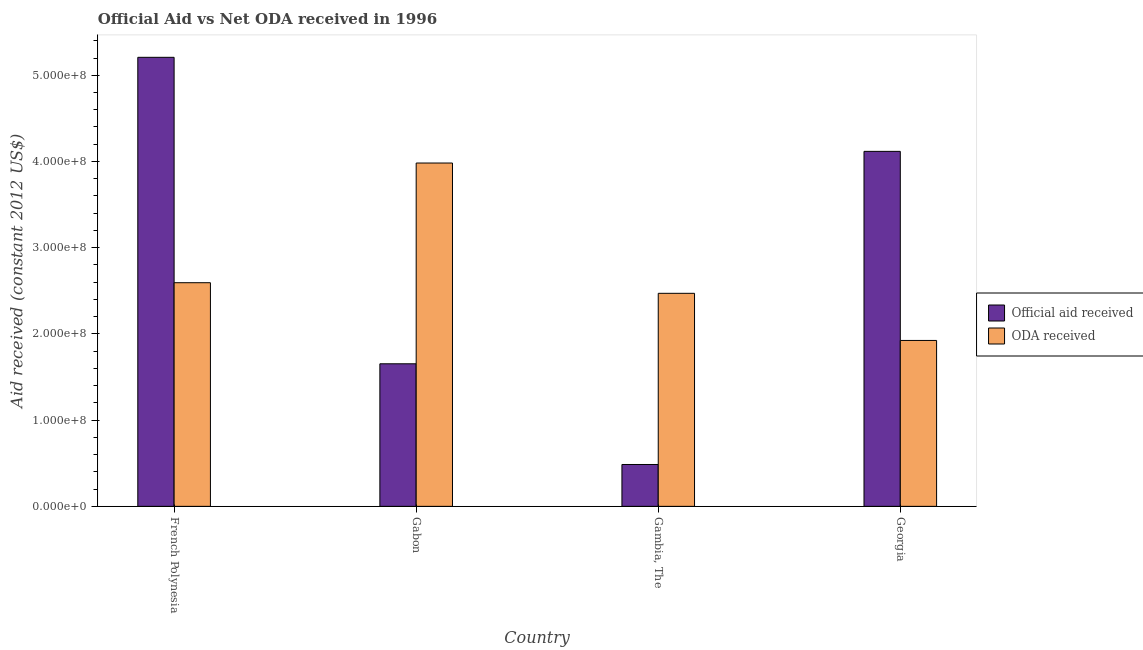How many different coloured bars are there?
Give a very brief answer. 2. How many groups of bars are there?
Offer a very short reply. 4. Are the number of bars on each tick of the X-axis equal?
Your response must be concise. Yes. What is the label of the 1st group of bars from the left?
Keep it short and to the point. French Polynesia. What is the oda received in Georgia?
Make the answer very short. 1.92e+08. Across all countries, what is the maximum oda received?
Make the answer very short. 3.98e+08. Across all countries, what is the minimum oda received?
Your answer should be compact. 1.92e+08. In which country was the official aid received maximum?
Your answer should be compact. French Polynesia. In which country was the official aid received minimum?
Make the answer very short. Gambia, The. What is the total official aid received in the graph?
Offer a very short reply. 1.15e+09. What is the difference between the official aid received in French Polynesia and that in Georgia?
Make the answer very short. 1.09e+08. What is the difference between the official aid received in French Polynesia and the oda received in Georgia?
Provide a succinct answer. 3.28e+08. What is the average official aid received per country?
Offer a very short reply. 2.87e+08. What is the difference between the oda received and official aid received in Georgia?
Keep it short and to the point. -2.19e+08. What is the ratio of the oda received in French Polynesia to that in Gabon?
Ensure brevity in your answer.  0.65. Is the difference between the oda received in Gabon and Georgia greater than the difference between the official aid received in Gabon and Georgia?
Your answer should be compact. Yes. What is the difference between the highest and the second highest official aid received?
Make the answer very short. 1.09e+08. What is the difference between the highest and the lowest official aid received?
Your response must be concise. 4.72e+08. In how many countries, is the official aid received greater than the average official aid received taken over all countries?
Your answer should be compact. 2. Is the sum of the oda received in French Polynesia and Gambia, The greater than the maximum official aid received across all countries?
Offer a terse response. No. What does the 2nd bar from the left in French Polynesia represents?
Make the answer very short. ODA received. What does the 2nd bar from the right in Gambia, The represents?
Offer a very short reply. Official aid received. How many bars are there?
Provide a succinct answer. 8. Are all the bars in the graph horizontal?
Your answer should be compact. No. Are the values on the major ticks of Y-axis written in scientific E-notation?
Offer a very short reply. Yes. Where does the legend appear in the graph?
Give a very brief answer. Center right. How many legend labels are there?
Offer a very short reply. 2. What is the title of the graph?
Give a very brief answer. Official Aid vs Net ODA received in 1996 . What is the label or title of the Y-axis?
Offer a very short reply. Aid received (constant 2012 US$). What is the Aid received (constant 2012 US$) in Official aid received in French Polynesia?
Your response must be concise. 5.21e+08. What is the Aid received (constant 2012 US$) in ODA received in French Polynesia?
Offer a very short reply. 2.59e+08. What is the Aid received (constant 2012 US$) in Official aid received in Gabon?
Give a very brief answer. 1.65e+08. What is the Aid received (constant 2012 US$) in ODA received in Gabon?
Your answer should be compact. 3.98e+08. What is the Aid received (constant 2012 US$) of Official aid received in Gambia, The?
Offer a terse response. 4.86e+07. What is the Aid received (constant 2012 US$) in ODA received in Gambia, The?
Offer a terse response. 2.47e+08. What is the Aid received (constant 2012 US$) of Official aid received in Georgia?
Offer a terse response. 4.12e+08. What is the Aid received (constant 2012 US$) in ODA received in Georgia?
Your answer should be very brief. 1.92e+08. Across all countries, what is the maximum Aid received (constant 2012 US$) of Official aid received?
Keep it short and to the point. 5.21e+08. Across all countries, what is the maximum Aid received (constant 2012 US$) in ODA received?
Provide a short and direct response. 3.98e+08. Across all countries, what is the minimum Aid received (constant 2012 US$) of Official aid received?
Offer a very short reply. 4.86e+07. Across all countries, what is the minimum Aid received (constant 2012 US$) in ODA received?
Offer a terse response. 1.92e+08. What is the total Aid received (constant 2012 US$) in Official aid received in the graph?
Provide a succinct answer. 1.15e+09. What is the total Aid received (constant 2012 US$) in ODA received in the graph?
Your answer should be very brief. 1.10e+09. What is the difference between the Aid received (constant 2012 US$) in Official aid received in French Polynesia and that in Gabon?
Make the answer very short. 3.55e+08. What is the difference between the Aid received (constant 2012 US$) of ODA received in French Polynesia and that in Gabon?
Ensure brevity in your answer.  -1.39e+08. What is the difference between the Aid received (constant 2012 US$) of Official aid received in French Polynesia and that in Gambia, The?
Offer a terse response. 4.72e+08. What is the difference between the Aid received (constant 2012 US$) in ODA received in French Polynesia and that in Gambia, The?
Provide a succinct answer. 1.23e+07. What is the difference between the Aid received (constant 2012 US$) in Official aid received in French Polynesia and that in Georgia?
Offer a very short reply. 1.09e+08. What is the difference between the Aid received (constant 2012 US$) of ODA received in French Polynesia and that in Georgia?
Offer a very short reply. 6.70e+07. What is the difference between the Aid received (constant 2012 US$) of Official aid received in Gabon and that in Gambia, The?
Keep it short and to the point. 1.17e+08. What is the difference between the Aid received (constant 2012 US$) in ODA received in Gabon and that in Gambia, The?
Give a very brief answer. 1.51e+08. What is the difference between the Aid received (constant 2012 US$) of Official aid received in Gabon and that in Georgia?
Your answer should be very brief. -2.46e+08. What is the difference between the Aid received (constant 2012 US$) of ODA received in Gabon and that in Georgia?
Your response must be concise. 2.06e+08. What is the difference between the Aid received (constant 2012 US$) of Official aid received in Gambia, The and that in Georgia?
Provide a short and direct response. -3.63e+08. What is the difference between the Aid received (constant 2012 US$) of ODA received in Gambia, The and that in Georgia?
Keep it short and to the point. 5.46e+07. What is the difference between the Aid received (constant 2012 US$) of Official aid received in French Polynesia and the Aid received (constant 2012 US$) of ODA received in Gabon?
Keep it short and to the point. 1.23e+08. What is the difference between the Aid received (constant 2012 US$) of Official aid received in French Polynesia and the Aid received (constant 2012 US$) of ODA received in Gambia, The?
Provide a succinct answer. 2.74e+08. What is the difference between the Aid received (constant 2012 US$) in Official aid received in French Polynesia and the Aid received (constant 2012 US$) in ODA received in Georgia?
Keep it short and to the point. 3.28e+08. What is the difference between the Aid received (constant 2012 US$) in Official aid received in Gabon and the Aid received (constant 2012 US$) in ODA received in Gambia, The?
Your response must be concise. -8.17e+07. What is the difference between the Aid received (constant 2012 US$) of Official aid received in Gabon and the Aid received (constant 2012 US$) of ODA received in Georgia?
Offer a very short reply. -2.71e+07. What is the difference between the Aid received (constant 2012 US$) in Official aid received in Gambia, The and the Aid received (constant 2012 US$) in ODA received in Georgia?
Your answer should be compact. -1.44e+08. What is the average Aid received (constant 2012 US$) in Official aid received per country?
Your answer should be compact. 2.87e+08. What is the average Aid received (constant 2012 US$) of ODA received per country?
Your answer should be very brief. 2.74e+08. What is the difference between the Aid received (constant 2012 US$) in Official aid received and Aid received (constant 2012 US$) in ODA received in French Polynesia?
Keep it short and to the point. 2.61e+08. What is the difference between the Aid received (constant 2012 US$) of Official aid received and Aid received (constant 2012 US$) of ODA received in Gabon?
Give a very brief answer. -2.33e+08. What is the difference between the Aid received (constant 2012 US$) of Official aid received and Aid received (constant 2012 US$) of ODA received in Gambia, The?
Your response must be concise. -1.99e+08. What is the difference between the Aid received (constant 2012 US$) of Official aid received and Aid received (constant 2012 US$) of ODA received in Georgia?
Provide a succinct answer. 2.19e+08. What is the ratio of the Aid received (constant 2012 US$) in Official aid received in French Polynesia to that in Gabon?
Ensure brevity in your answer.  3.15. What is the ratio of the Aid received (constant 2012 US$) of ODA received in French Polynesia to that in Gabon?
Offer a very short reply. 0.65. What is the ratio of the Aid received (constant 2012 US$) of Official aid received in French Polynesia to that in Gambia, The?
Make the answer very short. 10.73. What is the ratio of the Aid received (constant 2012 US$) in ODA received in French Polynesia to that in Gambia, The?
Your response must be concise. 1.05. What is the ratio of the Aid received (constant 2012 US$) of Official aid received in French Polynesia to that in Georgia?
Your answer should be compact. 1.26. What is the ratio of the Aid received (constant 2012 US$) of ODA received in French Polynesia to that in Georgia?
Your answer should be very brief. 1.35. What is the ratio of the Aid received (constant 2012 US$) of Official aid received in Gabon to that in Gambia, The?
Ensure brevity in your answer.  3.41. What is the ratio of the Aid received (constant 2012 US$) of ODA received in Gabon to that in Gambia, The?
Your answer should be compact. 1.61. What is the ratio of the Aid received (constant 2012 US$) in Official aid received in Gabon to that in Georgia?
Provide a short and direct response. 0.4. What is the ratio of the Aid received (constant 2012 US$) of ODA received in Gabon to that in Georgia?
Offer a terse response. 2.07. What is the ratio of the Aid received (constant 2012 US$) of Official aid received in Gambia, The to that in Georgia?
Ensure brevity in your answer.  0.12. What is the ratio of the Aid received (constant 2012 US$) in ODA received in Gambia, The to that in Georgia?
Provide a short and direct response. 1.28. What is the difference between the highest and the second highest Aid received (constant 2012 US$) of Official aid received?
Your answer should be very brief. 1.09e+08. What is the difference between the highest and the second highest Aid received (constant 2012 US$) in ODA received?
Provide a short and direct response. 1.39e+08. What is the difference between the highest and the lowest Aid received (constant 2012 US$) in Official aid received?
Offer a terse response. 4.72e+08. What is the difference between the highest and the lowest Aid received (constant 2012 US$) in ODA received?
Provide a succinct answer. 2.06e+08. 